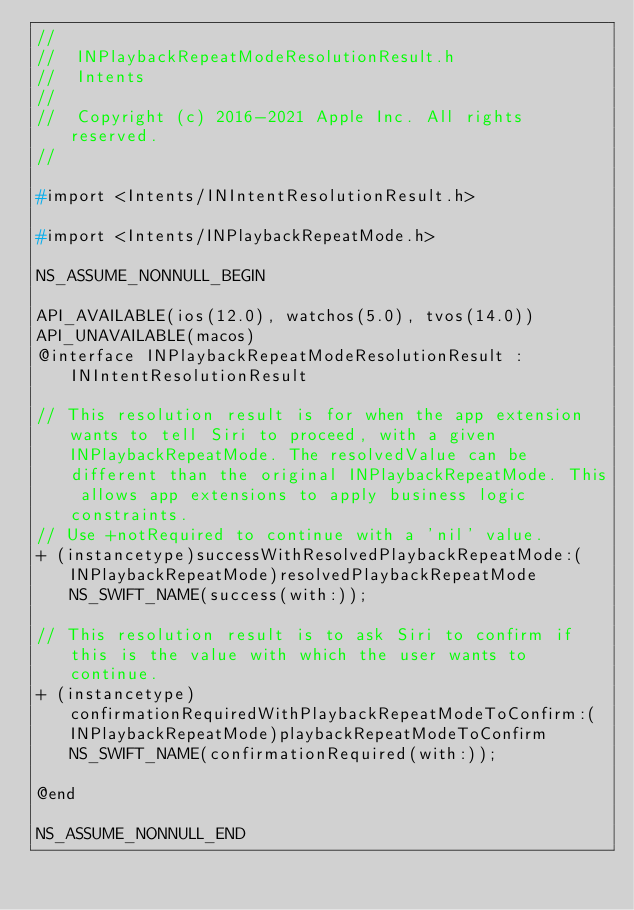Convert code to text. <code><loc_0><loc_0><loc_500><loc_500><_C_>//
//  INPlaybackRepeatModeResolutionResult.h
//  Intents
//
//  Copyright (c) 2016-2021 Apple Inc. All rights reserved.
//

#import <Intents/INIntentResolutionResult.h>

#import <Intents/INPlaybackRepeatMode.h>

NS_ASSUME_NONNULL_BEGIN

API_AVAILABLE(ios(12.0), watchos(5.0), tvos(14.0))
API_UNAVAILABLE(macos)
@interface INPlaybackRepeatModeResolutionResult : INIntentResolutionResult

// This resolution result is for when the app extension wants to tell Siri to proceed, with a given INPlaybackRepeatMode. The resolvedValue can be different than the original INPlaybackRepeatMode. This allows app extensions to apply business logic constraints.
// Use +notRequired to continue with a 'nil' value.
+ (instancetype)successWithResolvedPlaybackRepeatMode:(INPlaybackRepeatMode)resolvedPlaybackRepeatMode NS_SWIFT_NAME(success(with:));

// This resolution result is to ask Siri to confirm if this is the value with which the user wants to continue.
+ (instancetype)confirmationRequiredWithPlaybackRepeatModeToConfirm:(INPlaybackRepeatMode)playbackRepeatModeToConfirm NS_SWIFT_NAME(confirmationRequired(with:));

@end

NS_ASSUME_NONNULL_END
</code> 